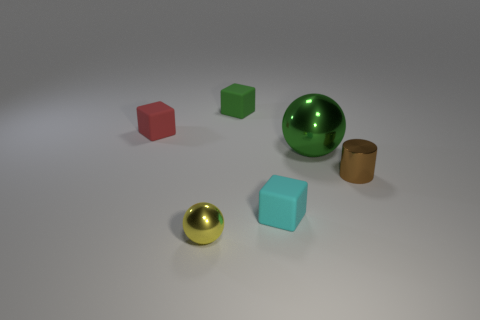Is the number of big objects right of the tiny brown cylinder the same as the number of cyan matte cubes that are on the right side of the green sphere?
Ensure brevity in your answer.  Yes. There is a green object that is on the right side of the tiny green object; is its shape the same as the tiny green matte thing?
Offer a terse response. No. There is a brown cylinder; is its size the same as the shiny ball that is behind the yellow sphere?
Offer a very short reply. No. What number of other objects are the same color as the big metallic sphere?
Your response must be concise. 1. Are there any small spheres to the right of the small brown cylinder?
Provide a short and direct response. No. How many things are either red objects or metal objects to the left of the brown metallic thing?
Ensure brevity in your answer.  3. There is a small metal object in front of the cylinder; are there any metallic cylinders that are to the right of it?
Ensure brevity in your answer.  Yes. What shape is the metal thing in front of the small metallic object on the right side of the cube right of the small green thing?
Your answer should be compact. Sphere. There is a tiny object that is on the left side of the small cyan rubber cube and in front of the cylinder; what is its color?
Offer a very short reply. Yellow. What is the shape of the matte object that is in front of the tiny red block?
Ensure brevity in your answer.  Cube. 